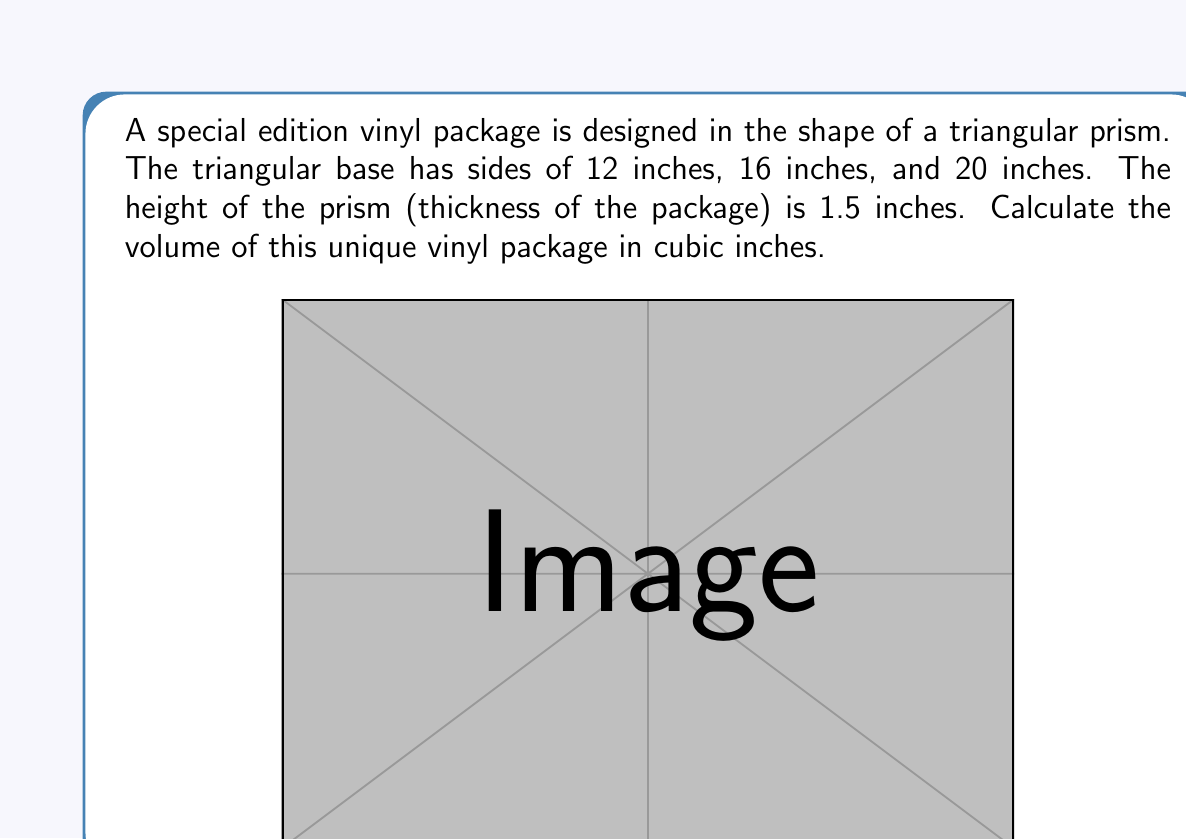Give your solution to this math problem. To find the volume of a triangular prism, we need to calculate the area of the triangular base and multiply it by the height of the prism. Let's break this down step-by-step:

1) First, we need to calculate the area of the triangular base. We can use Heron's formula for this:

   $A = \sqrt{s(s-a)(s-b)(s-c)}$

   where $s$ is the semi-perimeter, and $a$, $b$, and $c$ are the sides of the triangle.

2) Calculate the semi-perimeter:
   $s = \frac{a + b + c}{2} = \frac{12 + 16 + 20}{2} = 24$ inches

3) Now we can apply Heron's formula:
   $$A = \sqrt{24(24-12)(24-16)(24-20)}$$
   $$A = \sqrt{24 \cdot 12 \cdot 8 \cdot 4}$$
   $$A = \sqrt{9216} = 96$$ square inches

4) The volume of a prism is given by the formula:
   $V = Ah$, where $A$ is the area of the base and $h$ is the height of the prism.

5) Substituting our values:
   $V = 96 \cdot 1.5 = 144$ cubic inches

Therefore, the volume of the triangular prism-shaped vinyl package is 144 cubic inches.
Answer: 144 cubic inches 